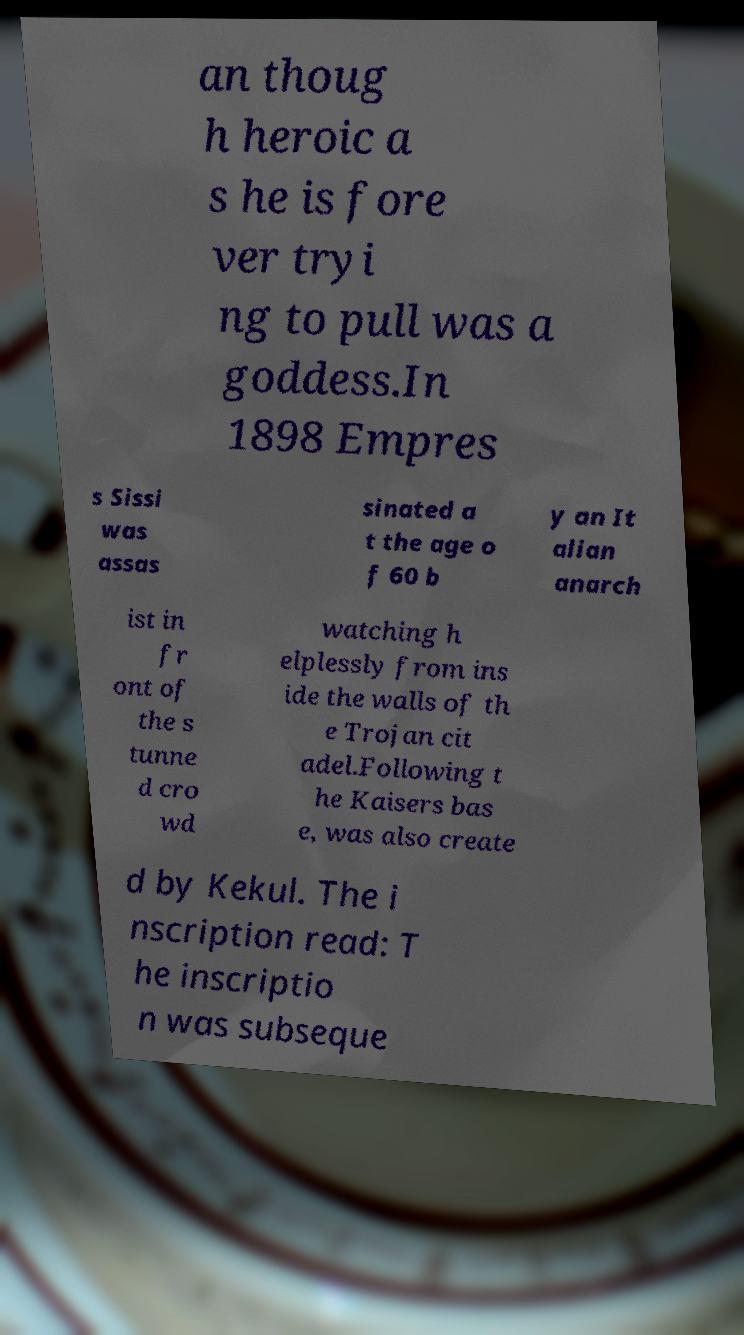I need the written content from this picture converted into text. Can you do that? an thoug h heroic a s he is fore ver tryi ng to pull was a goddess.In 1898 Empres s Sissi was assas sinated a t the age o f 60 b y an It alian anarch ist in fr ont of the s tunne d cro wd watching h elplessly from ins ide the walls of th e Trojan cit adel.Following t he Kaisers bas e, was also create d by Kekul. The i nscription read: T he inscriptio n was subseque 